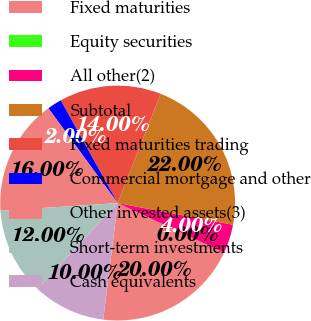<chart> <loc_0><loc_0><loc_500><loc_500><pie_chart><fcel>Fixed maturities<fcel>Equity securities<fcel>All other(2)<fcel>Subtotal<fcel>Fixed maturities trading<fcel>Commercial mortgage and other<fcel>Other invested assets(3)<fcel>Short-term investments<fcel>Cash equivalents<nl><fcel>20.0%<fcel>0.0%<fcel>4.0%<fcel>22.0%<fcel>14.0%<fcel>2.0%<fcel>16.0%<fcel>12.0%<fcel>10.0%<nl></chart> 